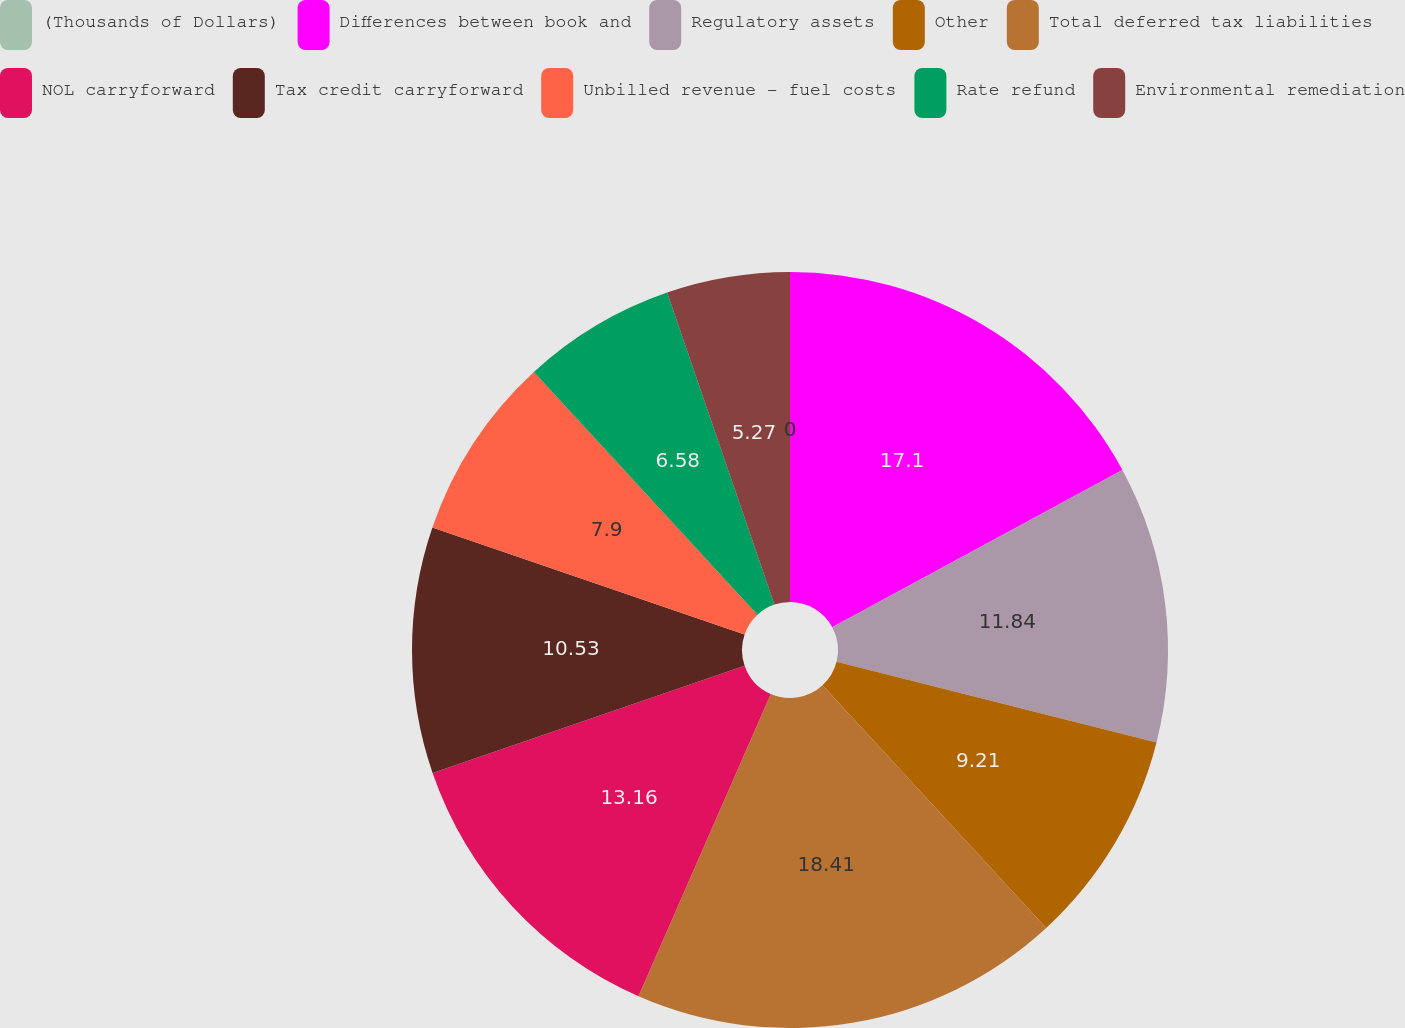<chart> <loc_0><loc_0><loc_500><loc_500><pie_chart><fcel>(Thousands of Dollars)<fcel>Differences between book and<fcel>Regulatory assets<fcel>Other<fcel>Total deferred tax liabilities<fcel>NOL carryforward<fcel>Tax credit carryforward<fcel>Unbilled revenue - fuel costs<fcel>Rate refund<fcel>Environmental remediation<nl><fcel>0.0%<fcel>17.1%<fcel>11.84%<fcel>9.21%<fcel>18.42%<fcel>13.16%<fcel>10.53%<fcel>7.9%<fcel>6.58%<fcel>5.27%<nl></chart> 